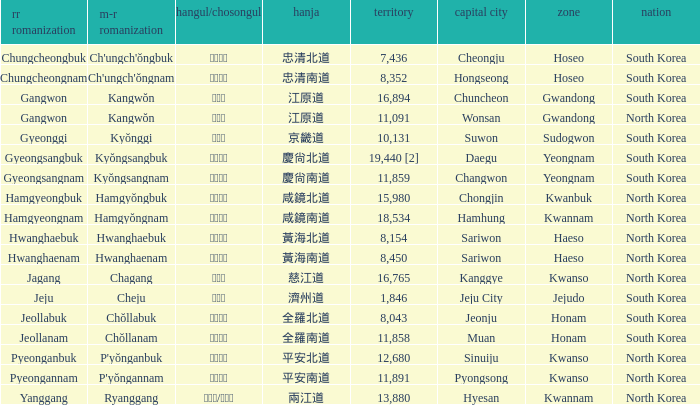What is the RR Romaja for the province that has Hangul of 강원도 and capital of Wonsan? Gangwon. 